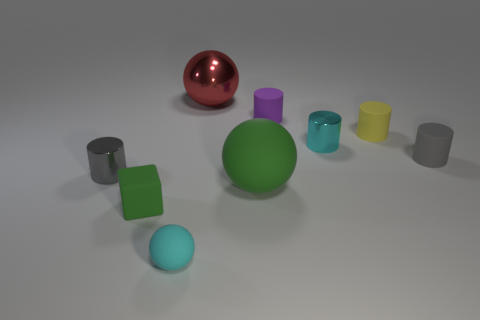Subtract all tiny gray cylinders. How many cylinders are left? 3 Add 1 small gray rubber cylinders. How many objects exist? 10 Subtract all yellow cylinders. How many cylinders are left? 4 Subtract 2 balls. How many balls are left? 1 Add 4 green rubber cubes. How many green rubber cubes exist? 5 Subtract 0 cyan blocks. How many objects are left? 9 Subtract all spheres. How many objects are left? 6 Subtract all cyan cubes. Subtract all green spheres. How many cubes are left? 1 Subtract all purple blocks. How many purple cylinders are left? 1 Subtract all small green matte cubes. Subtract all large red cubes. How many objects are left? 8 